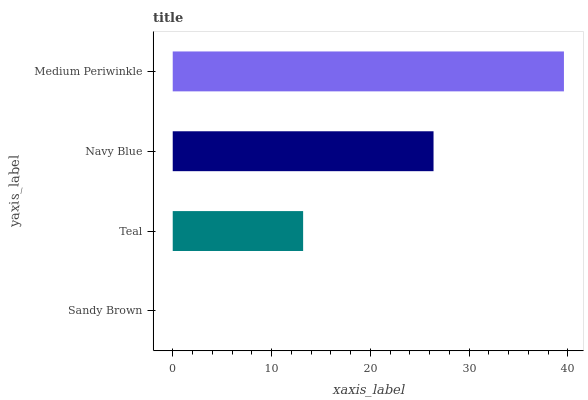Is Sandy Brown the minimum?
Answer yes or no. Yes. Is Medium Periwinkle the maximum?
Answer yes or no. Yes. Is Teal the minimum?
Answer yes or no. No. Is Teal the maximum?
Answer yes or no. No. Is Teal greater than Sandy Brown?
Answer yes or no. Yes. Is Sandy Brown less than Teal?
Answer yes or no. Yes. Is Sandy Brown greater than Teal?
Answer yes or no. No. Is Teal less than Sandy Brown?
Answer yes or no. No. Is Navy Blue the high median?
Answer yes or no. Yes. Is Teal the low median?
Answer yes or no. Yes. Is Teal the high median?
Answer yes or no. No. Is Sandy Brown the low median?
Answer yes or no. No. 